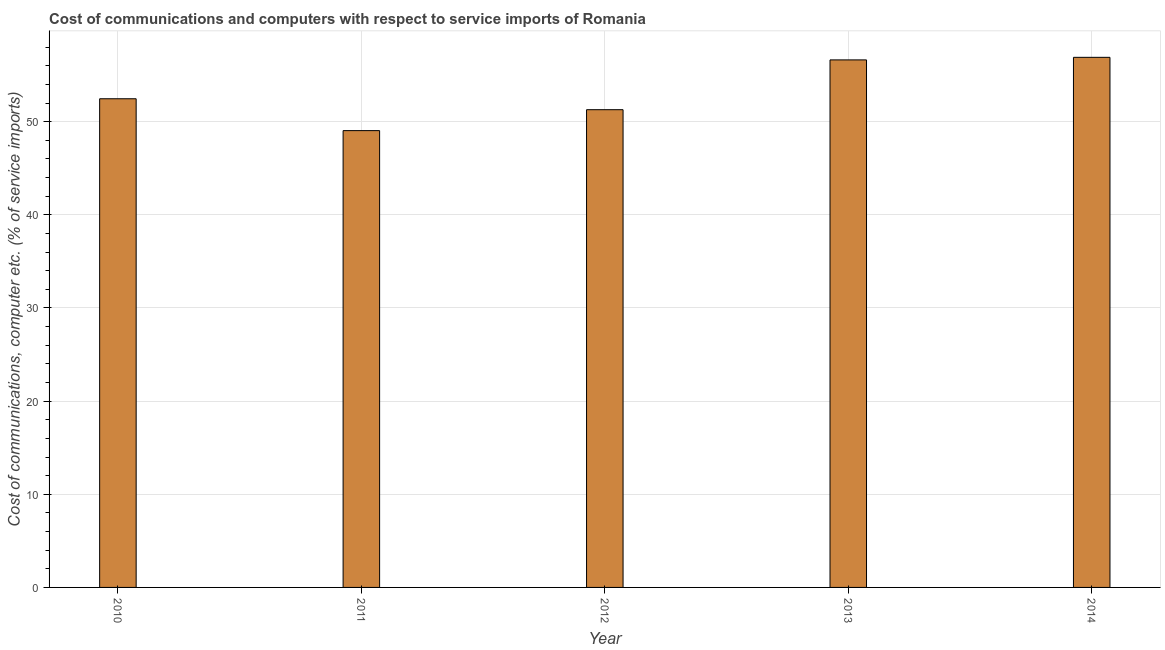Does the graph contain any zero values?
Ensure brevity in your answer.  No. What is the title of the graph?
Make the answer very short. Cost of communications and computers with respect to service imports of Romania. What is the label or title of the Y-axis?
Provide a short and direct response. Cost of communications, computer etc. (% of service imports). What is the cost of communications and computer in 2013?
Provide a short and direct response. 56.63. Across all years, what is the maximum cost of communications and computer?
Your response must be concise. 56.91. Across all years, what is the minimum cost of communications and computer?
Provide a succinct answer. 49.04. What is the sum of the cost of communications and computer?
Provide a succinct answer. 266.33. What is the difference between the cost of communications and computer in 2010 and 2013?
Your answer should be compact. -4.17. What is the average cost of communications and computer per year?
Provide a succinct answer. 53.27. What is the median cost of communications and computer?
Keep it short and to the point. 52.46. In how many years, is the cost of communications and computer greater than 54 %?
Ensure brevity in your answer.  2. What is the ratio of the cost of communications and computer in 2011 to that in 2013?
Your response must be concise. 0.87. What is the difference between the highest and the second highest cost of communications and computer?
Offer a terse response. 0.28. What is the difference between the highest and the lowest cost of communications and computer?
Your response must be concise. 7.87. How many bars are there?
Offer a terse response. 5. What is the difference between two consecutive major ticks on the Y-axis?
Keep it short and to the point. 10. What is the Cost of communications, computer etc. (% of service imports) in 2010?
Provide a short and direct response. 52.46. What is the Cost of communications, computer etc. (% of service imports) in 2011?
Your answer should be compact. 49.04. What is the Cost of communications, computer etc. (% of service imports) in 2012?
Your response must be concise. 51.29. What is the Cost of communications, computer etc. (% of service imports) in 2013?
Keep it short and to the point. 56.63. What is the Cost of communications, computer etc. (% of service imports) in 2014?
Make the answer very short. 56.91. What is the difference between the Cost of communications, computer etc. (% of service imports) in 2010 and 2011?
Your answer should be compact. 3.42. What is the difference between the Cost of communications, computer etc. (% of service imports) in 2010 and 2012?
Provide a short and direct response. 1.17. What is the difference between the Cost of communications, computer etc. (% of service imports) in 2010 and 2013?
Offer a very short reply. -4.17. What is the difference between the Cost of communications, computer etc. (% of service imports) in 2010 and 2014?
Provide a succinct answer. -4.45. What is the difference between the Cost of communications, computer etc. (% of service imports) in 2011 and 2012?
Your response must be concise. -2.25. What is the difference between the Cost of communications, computer etc. (% of service imports) in 2011 and 2013?
Give a very brief answer. -7.59. What is the difference between the Cost of communications, computer etc. (% of service imports) in 2011 and 2014?
Offer a terse response. -7.87. What is the difference between the Cost of communications, computer etc. (% of service imports) in 2012 and 2013?
Give a very brief answer. -5.35. What is the difference between the Cost of communications, computer etc. (% of service imports) in 2012 and 2014?
Your answer should be very brief. -5.62. What is the difference between the Cost of communications, computer etc. (% of service imports) in 2013 and 2014?
Your answer should be compact. -0.28. What is the ratio of the Cost of communications, computer etc. (% of service imports) in 2010 to that in 2011?
Provide a short and direct response. 1.07. What is the ratio of the Cost of communications, computer etc. (% of service imports) in 2010 to that in 2012?
Give a very brief answer. 1.02. What is the ratio of the Cost of communications, computer etc. (% of service imports) in 2010 to that in 2013?
Offer a very short reply. 0.93. What is the ratio of the Cost of communications, computer etc. (% of service imports) in 2010 to that in 2014?
Offer a terse response. 0.92. What is the ratio of the Cost of communications, computer etc. (% of service imports) in 2011 to that in 2012?
Your answer should be compact. 0.96. What is the ratio of the Cost of communications, computer etc. (% of service imports) in 2011 to that in 2013?
Provide a succinct answer. 0.87. What is the ratio of the Cost of communications, computer etc. (% of service imports) in 2011 to that in 2014?
Offer a terse response. 0.86. What is the ratio of the Cost of communications, computer etc. (% of service imports) in 2012 to that in 2013?
Offer a very short reply. 0.91. What is the ratio of the Cost of communications, computer etc. (% of service imports) in 2012 to that in 2014?
Ensure brevity in your answer.  0.9. What is the ratio of the Cost of communications, computer etc. (% of service imports) in 2013 to that in 2014?
Give a very brief answer. 0.99. 